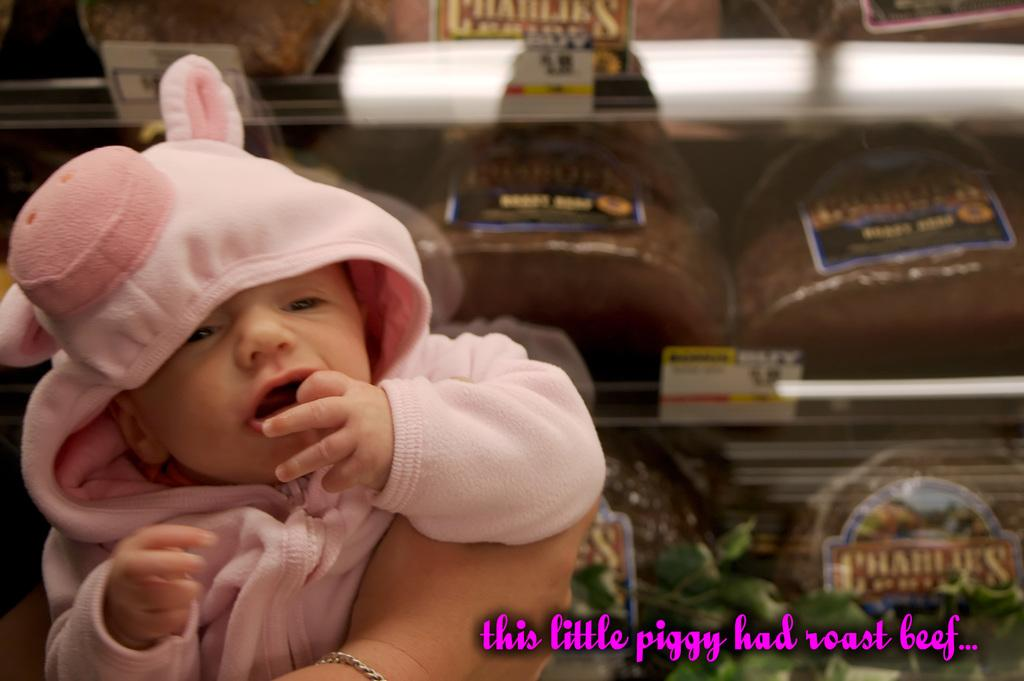What is the main subject of the image? There is an infant in the image. Can you describe the infant's clothing? The infant is wearing a pink dress. What can be seen in the background of the image? There is a rack in the background of the image. What is on the rack? The rack contains many things. What type of nerve can be seen in the image? There is no nerve present in the image; it features an infant wearing a pink dress and a rack in the background. Can you tell me how many zebras are visible in the image? There are no zebras present in the image. 